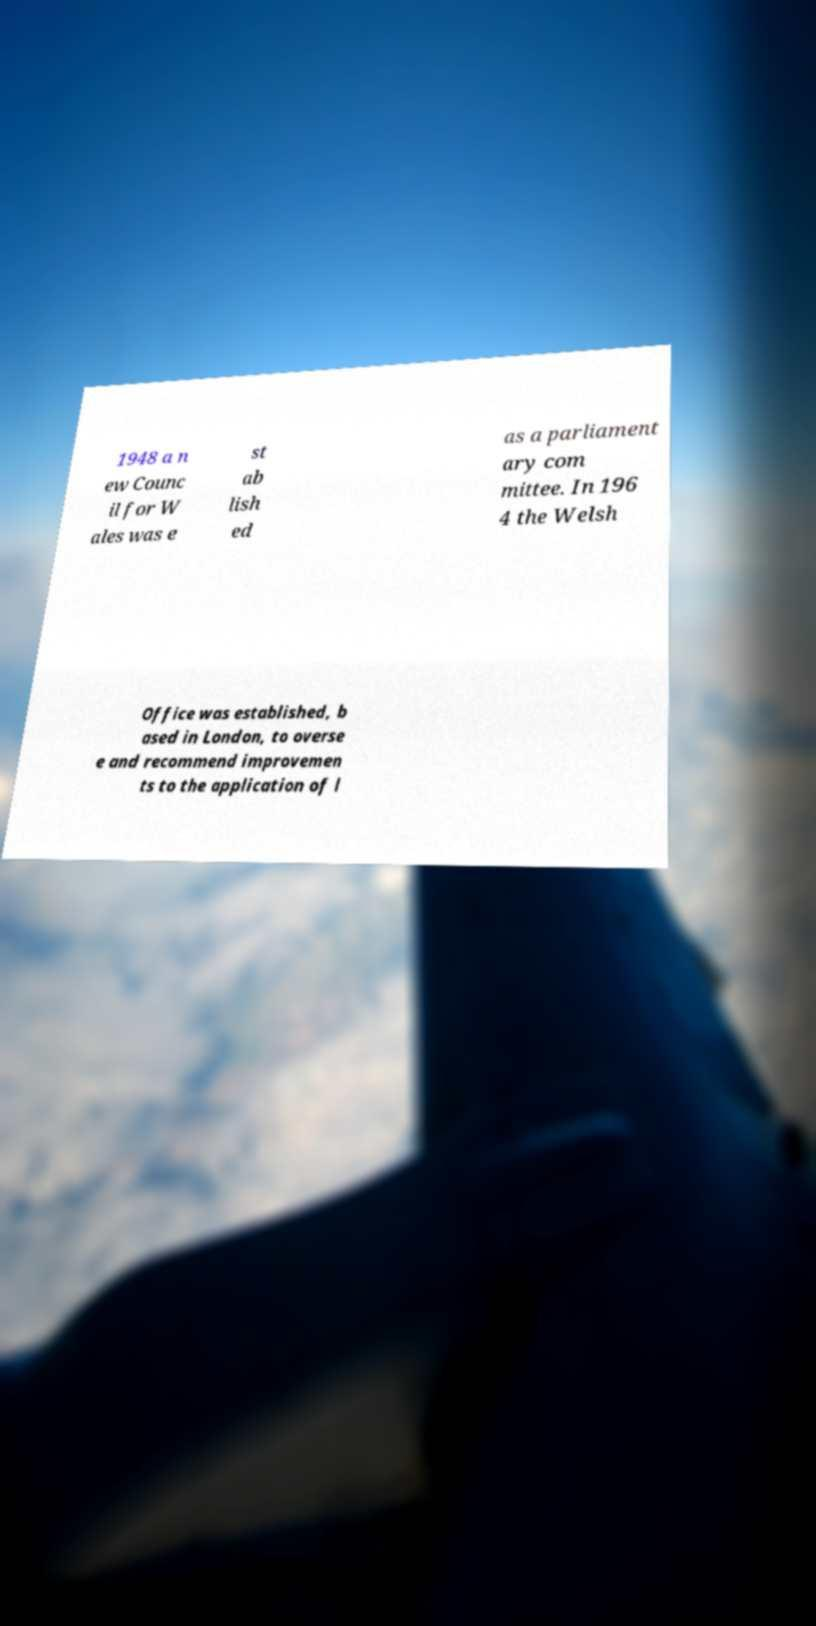There's text embedded in this image that I need extracted. Can you transcribe it verbatim? 1948 a n ew Counc il for W ales was e st ab lish ed as a parliament ary com mittee. In 196 4 the Welsh Office was established, b ased in London, to overse e and recommend improvemen ts to the application of l 